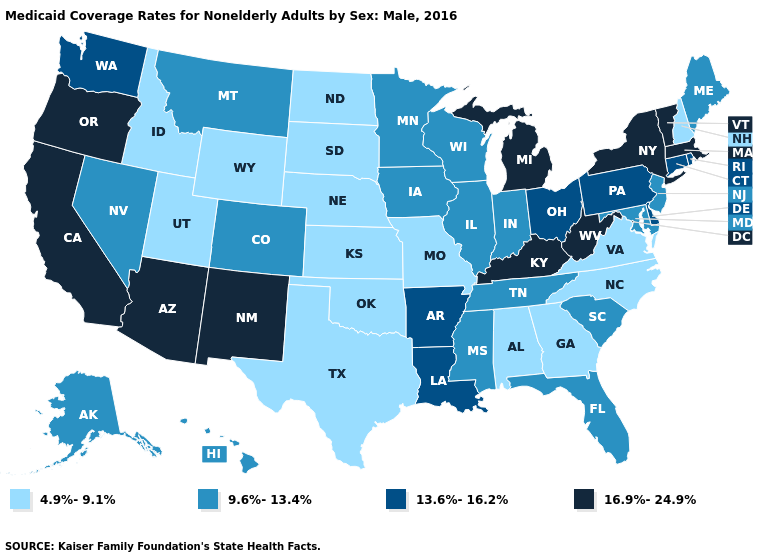Does Connecticut have a lower value than New Jersey?
Give a very brief answer. No. What is the lowest value in the USA?
Write a very short answer. 4.9%-9.1%. What is the value of Montana?
Concise answer only. 9.6%-13.4%. What is the value of Florida?
Give a very brief answer. 9.6%-13.4%. What is the value of Oregon?
Quick response, please. 16.9%-24.9%. Among the states that border Indiana , does Michigan have the highest value?
Answer briefly. Yes. What is the lowest value in the USA?
Quick response, please. 4.9%-9.1%. What is the value of Oregon?
Give a very brief answer. 16.9%-24.9%. Among the states that border New York , does New Jersey have the highest value?
Be succinct. No. Name the states that have a value in the range 13.6%-16.2%?
Quick response, please. Arkansas, Connecticut, Delaware, Louisiana, Ohio, Pennsylvania, Rhode Island, Washington. What is the value of Kentucky?
Answer briefly. 16.9%-24.9%. Among the states that border New Jersey , does New York have the highest value?
Concise answer only. Yes. Name the states that have a value in the range 16.9%-24.9%?
Quick response, please. Arizona, California, Kentucky, Massachusetts, Michigan, New Mexico, New York, Oregon, Vermont, West Virginia. Does Rhode Island have a lower value than New Mexico?
Keep it brief. Yes. What is the lowest value in the USA?
Quick response, please. 4.9%-9.1%. 